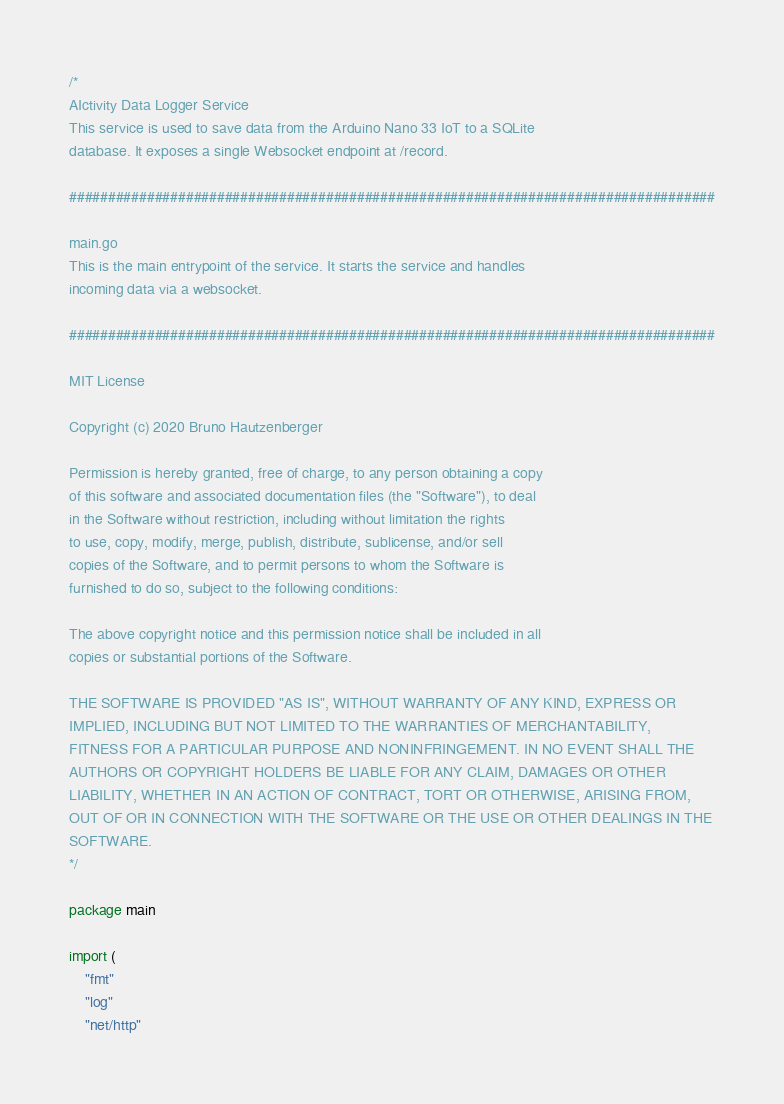Convert code to text. <code><loc_0><loc_0><loc_500><loc_500><_Go_>/*
AIctivity Data Logger Service
This service is used to save data from the Arduino Nano 33 IoT to a SQLite
database. It exposes a single Websocket endpoint at /record.

###################################################################################

main.go
This is the main entrypoint of the service. It starts the service and handles
incoming data via a websocket.

###################################################################################

MIT License

Copyright (c) 2020 Bruno Hautzenberger

Permission is hereby granted, free of charge, to any person obtaining a copy
of this software and associated documentation files (the "Software"), to deal
in the Software without restriction, including without limitation the rights
to use, copy, modify, merge, publish, distribute, sublicense, and/or sell
copies of the Software, and to permit persons to whom the Software is
furnished to do so, subject to the following conditions:

The above copyright notice and this permission notice shall be included in all
copies or substantial portions of the Software.

THE SOFTWARE IS PROVIDED "AS IS", WITHOUT WARRANTY OF ANY KIND, EXPRESS OR
IMPLIED, INCLUDING BUT NOT LIMITED TO THE WARRANTIES OF MERCHANTABILITY,
FITNESS FOR A PARTICULAR PURPOSE AND NONINFRINGEMENT. IN NO EVENT SHALL THE
AUTHORS OR COPYRIGHT HOLDERS BE LIABLE FOR ANY CLAIM, DAMAGES OR OTHER
LIABILITY, WHETHER IN AN ACTION OF CONTRACT, TORT OR OTHERWISE, ARISING FROM,
OUT OF OR IN CONNECTION WITH THE SOFTWARE OR THE USE OR OTHER DEALINGS IN THE
SOFTWARE.
*/

package main

import (
	"fmt"
	"log"
	"net/http"</code> 